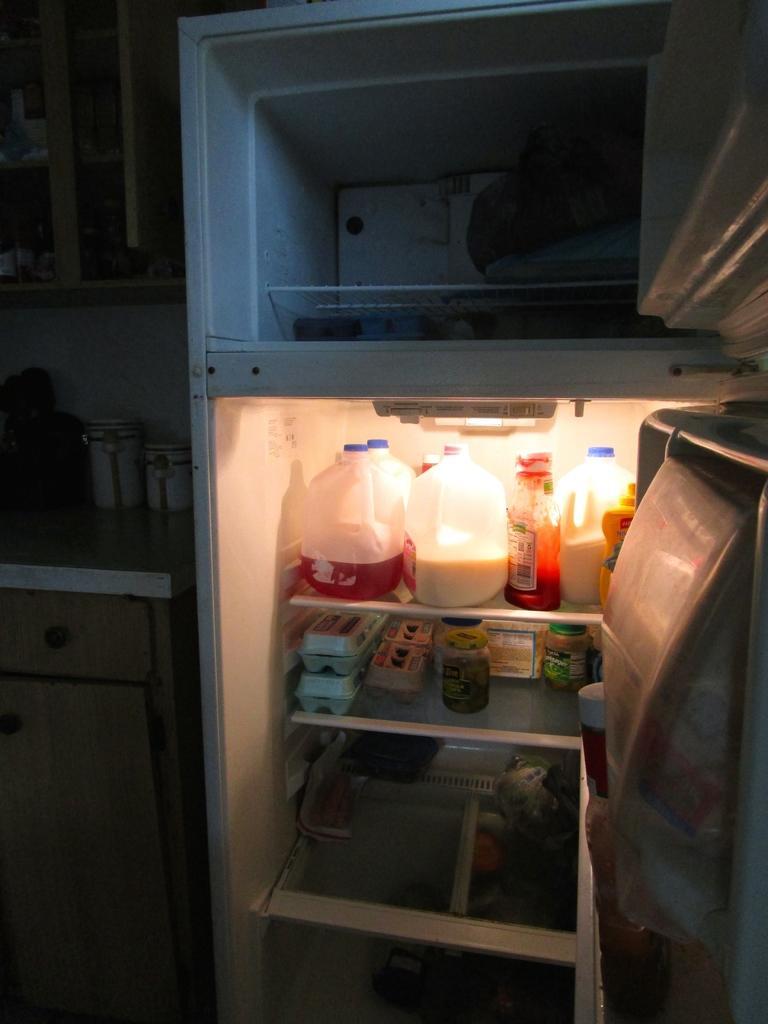Could you give a brief overview of what you see in this image? In the foreground of this image, there is a fridge. On the right, there are doors of it and we can also see few products inside it. On the left, there is a cupboard, two tins on the table and a shelf at the top. 